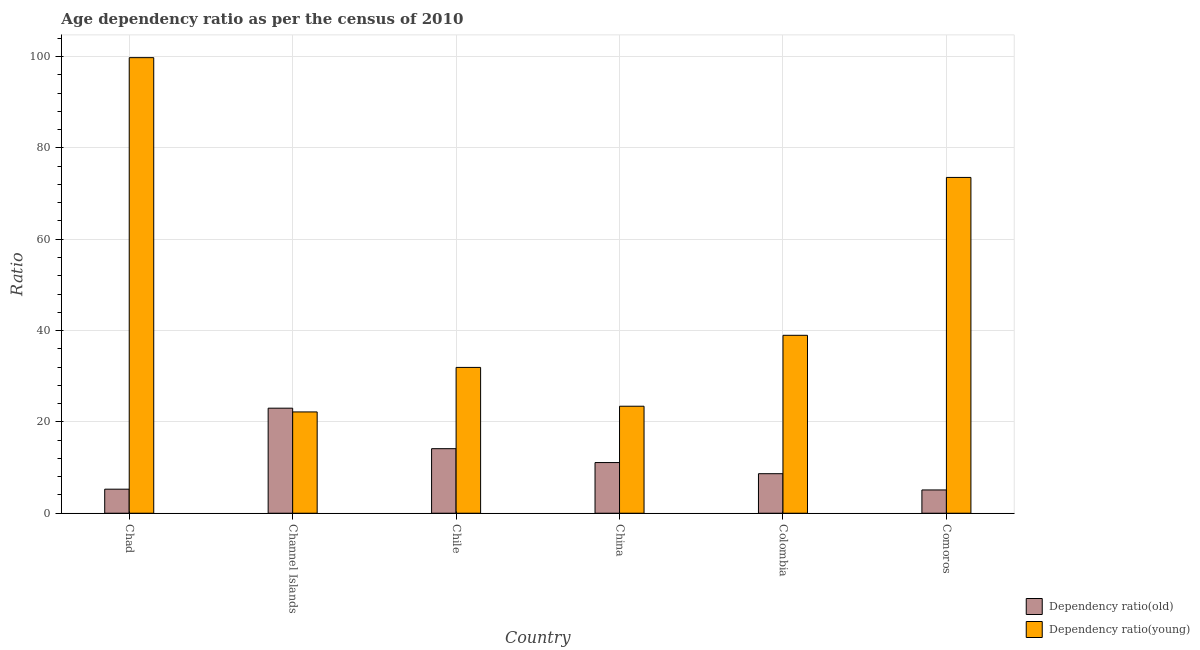How many bars are there on the 3rd tick from the right?
Provide a short and direct response. 2. What is the label of the 5th group of bars from the left?
Provide a short and direct response. Colombia. In how many cases, is the number of bars for a given country not equal to the number of legend labels?
Provide a succinct answer. 0. What is the age dependency ratio(old) in Colombia?
Your answer should be very brief. 8.66. Across all countries, what is the maximum age dependency ratio(old)?
Your answer should be compact. 23. Across all countries, what is the minimum age dependency ratio(young)?
Give a very brief answer. 22.18. In which country was the age dependency ratio(old) maximum?
Make the answer very short. Channel Islands. In which country was the age dependency ratio(old) minimum?
Your answer should be compact. Comoros. What is the total age dependency ratio(old) in the graph?
Offer a very short reply. 67.24. What is the difference between the age dependency ratio(young) in Chile and that in Colombia?
Give a very brief answer. -7.03. What is the difference between the age dependency ratio(young) in Channel Islands and the age dependency ratio(old) in Colombia?
Make the answer very short. 13.52. What is the average age dependency ratio(young) per country?
Give a very brief answer. 48.29. What is the difference between the age dependency ratio(old) and age dependency ratio(young) in China?
Make the answer very short. -12.33. In how many countries, is the age dependency ratio(young) greater than 84 ?
Ensure brevity in your answer.  1. What is the ratio of the age dependency ratio(old) in Chad to that in Chile?
Provide a short and direct response. 0.37. Is the age dependency ratio(young) in Colombia less than that in Comoros?
Keep it short and to the point. Yes. Is the difference between the age dependency ratio(young) in Chile and China greater than the difference between the age dependency ratio(old) in Chile and China?
Ensure brevity in your answer.  Yes. What is the difference between the highest and the second highest age dependency ratio(old)?
Offer a very short reply. 8.87. What is the difference between the highest and the lowest age dependency ratio(old)?
Your answer should be very brief. 17.91. In how many countries, is the age dependency ratio(young) greater than the average age dependency ratio(young) taken over all countries?
Provide a short and direct response. 2. What does the 1st bar from the left in Chile represents?
Your answer should be very brief. Dependency ratio(old). What does the 1st bar from the right in Channel Islands represents?
Your response must be concise. Dependency ratio(young). How many bars are there?
Provide a short and direct response. 12. What is the difference between two consecutive major ticks on the Y-axis?
Provide a succinct answer. 20. Where does the legend appear in the graph?
Keep it short and to the point. Bottom right. How many legend labels are there?
Keep it short and to the point. 2. How are the legend labels stacked?
Provide a short and direct response. Vertical. What is the title of the graph?
Offer a terse response. Age dependency ratio as per the census of 2010. What is the label or title of the Y-axis?
Provide a succinct answer. Ratio. What is the Ratio in Dependency ratio(old) in Chad?
Ensure brevity in your answer.  5.26. What is the Ratio of Dependency ratio(young) in Chad?
Offer a very short reply. 99.75. What is the Ratio in Dependency ratio(old) in Channel Islands?
Keep it short and to the point. 23. What is the Ratio in Dependency ratio(young) in Channel Islands?
Your answer should be compact. 22.18. What is the Ratio of Dependency ratio(old) in Chile?
Give a very brief answer. 14.13. What is the Ratio in Dependency ratio(young) in Chile?
Your answer should be compact. 31.93. What is the Ratio in Dependency ratio(old) in China?
Give a very brief answer. 11.09. What is the Ratio of Dependency ratio(young) in China?
Give a very brief answer. 23.43. What is the Ratio in Dependency ratio(old) in Colombia?
Your answer should be very brief. 8.66. What is the Ratio in Dependency ratio(young) in Colombia?
Keep it short and to the point. 38.96. What is the Ratio in Dependency ratio(old) in Comoros?
Provide a short and direct response. 5.1. What is the Ratio of Dependency ratio(young) in Comoros?
Your answer should be very brief. 73.53. Across all countries, what is the maximum Ratio of Dependency ratio(old)?
Make the answer very short. 23. Across all countries, what is the maximum Ratio in Dependency ratio(young)?
Give a very brief answer. 99.75. Across all countries, what is the minimum Ratio of Dependency ratio(old)?
Keep it short and to the point. 5.1. Across all countries, what is the minimum Ratio in Dependency ratio(young)?
Make the answer very short. 22.18. What is the total Ratio in Dependency ratio(old) in the graph?
Your answer should be very brief. 67.24. What is the total Ratio in Dependency ratio(young) in the graph?
Give a very brief answer. 289.77. What is the difference between the Ratio of Dependency ratio(old) in Chad and that in Channel Islands?
Offer a very short reply. -17.74. What is the difference between the Ratio in Dependency ratio(young) in Chad and that in Channel Islands?
Offer a very short reply. 77.57. What is the difference between the Ratio in Dependency ratio(old) in Chad and that in Chile?
Provide a short and direct response. -8.87. What is the difference between the Ratio in Dependency ratio(young) in Chad and that in Chile?
Your response must be concise. 67.83. What is the difference between the Ratio in Dependency ratio(old) in Chad and that in China?
Offer a very short reply. -5.83. What is the difference between the Ratio of Dependency ratio(young) in Chad and that in China?
Make the answer very short. 76.33. What is the difference between the Ratio in Dependency ratio(old) in Chad and that in Colombia?
Offer a very short reply. -3.39. What is the difference between the Ratio of Dependency ratio(young) in Chad and that in Colombia?
Your answer should be compact. 60.79. What is the difference between the Ratio in Dependency ratio(old) in Chad and that in Comoros?
Keep it short and to the point. 0.17. What is the difference between the Ratio of Dependency ratio(young) in Chad and that in Comoros?
Keep it short and to the point. 26.23. What is the difference between the Ratio of Dependency ratio(old) in Channel Islands and that in Chile?
Provide a succinct answer. 8.87. What is the difference between the Ratio of Dependency ratio(young) in Channel Islands and that in Chile?
Provide a short and direct response. -9.75. What is the difference between the Ratio of Dependency ratio(old) in Channel Islands and that in China?
Keep it short and to the point. 11.91. What is the difference between the Ratio of Dependency ratio(young) in Channel Islands and that in China?
Offer a terse response. -1.25. What is the difference between the Ratio in Dependency ratio(old) in Channel Islands and that in Colombia?
Keep it short and to the point. 14.35. What is the difference between the Ratio of Dependency ratio(young) in Channel Islands and that in Colombia?
Keep it short and to the point. -16.78. What is the difference between the Ratio of Dependency ratio(old) in Channel Islands and that in Comoros?
Provide a succinct answer. 17.91. What is the difference between the Ratio of Dependency ratio(young) in Channel Islands and that in Comoros?
Give a very brief answer. -51.35. What is the difference between the Ratio in Dependency ratio(old) in Chile and that in China?
Offer a terse response. 3.04. What is the difference between the Ratio in Dependency ratio(young) in Chile and that in China?
Keep it short and to the point. 8.5. What is the difference between the Ratio of Dependency ratio(old) in Chile and that in Colombia?
Provide a short and direct response. 5.48. What is the difference between the Ratio of Dependency ratio(young) in Chile and that in Colombia?
Provide a succinct answer. -7.03. What is the difference between the Ratio in Dependency ratio(old) in Chile and that in Comoros?
Your response must be concise. 9.03. What is the difference between the Ratio of Dependency ratio(young) in Chile and that in Comoros?
Your answer should be compact. -41.6. What is the difference between the Ratio in Dependency ratio(old) in China and that in Colombia?
Offer a terse response. 2.44. What is the difference between the Ratio of Dependency ratio(young) in China and that in Colombia?
Ensure brevity in your answer.  -15.53. What is the difference between the Ratio in Dependency ratio(old) in China and that in Comoros?
Your answer should be compact. 6. What is the difference between the Ratio in Dependency ratio(young) in China and that in Comoros?
Provide a short and direct response. -50.1. What is the difference between the Ratio of Dependency ratio(old) in Colombia and that in Comoros?
Your answer should be very brief. 3.56. What is the difference between the Ratio in Dependency ratio(young) in Colombia and that in Comoros?
Make the answer very short. -34.57. What is the difference between the Ratio of Dependency ratio(old) in Chad and the Ratio of Dependency ratio(young) in Channel Islands?
Offer a very short reply. -16.92. What is the difference between the Ratio in Dependency ratio(old) in Chad and the Ratio in Dependency ratio(young) in Chile?
Offer a very short reply. -26.66. What is the difference between the Ratio of Dependency ratio(old) in Chad and the Ratio of Dependency ratio(young) in China?
Offer a terse response. -18.16. What is the difference between the Ratio of Dependency ratio(old) in Chad and the Ratio of Dependency ratio(young) in Colombia?
Your response must be concise. -33.69. What is the difference between the Ratio of Dependency ratio(old) in Chad and the Ratio of Dependency ratio(young) in Comoros?
Provide a short and direct response. -68.26. What is the difference between the Ratio of Dependency ratio(old) in Channel Islands and the Ratio of Dependency ratio(young) in Chile?
Give a very brief answer. -8.93. What is the difference between the Ratio in Dependency ratio(old) in Channel Islands and the Ratio in Dependency ratio(young) in China?
Offer a very short reply. -0.42. What is the difference between the Ratio of Dependency ratio(old) in Channel Islands and the Ratio of Dependency ratio(young) in Colombia?
Ensure brevity in your answer.  -15.96. What is the difference between the Ratio in Dependency ratio(old) in Channel Islands and the Ratio in Dependency ratio(young) in Comoros?
Provide a short and direct response. -50.52. What is the difference between the Ratio of Dependency ratio(old) in Chile and the Ratio of Dependency ratio(young) in China?
Offer a terse response. -9.3. What is the difference between the Ratio in Dependency ratio(old) in Chile and the Ratio in Dependency ratio(young) in Colombia?
Your answer should be very brief. -24.83. What is the difference between the Ratio in Dependency ratio(old) in Chile and the Ratio in Dependency ratio(young) in Comoros?
Keep it short and to the point. -59.39. What is the difference between the Ratio in Dependency ratio(old) in China and the Ratio in Dependency ratio(young) in Colombia?
Offer a very short reply. -27.87. What is the difference between the Ratio of Dependency ratio(old) in China and the Ratio of Dependency ratio(young) in Comoros?
Keep it short and to the point. -62.43. What is the difference between the Ratio of Dependency ratio(old) in Colombia and the Ratio of Dependency ratio(young) in Comoros?
Your response must be concise. -64.87. What is the average Ratio of Dependency ratio(old) per country?
Your answer should be very brief. 11.21. What is the average Ratio of Dependency ratio(young) per country?
Offer a terse response. 48.29. What is the difference between the Ratio of Dependency ratio(old) and Ratio of Dependency ratio(young) in Chad?
Your answer should be compact. -94.49. What is the difference between the Ratio of Dependency ratio(old) and Ratio of Dependency ratio(young) in Channel Islands?
Keep it short and to the point. 0.82. What is the difference between the Ratio in Dependency ratio(old) and Ratio in Dependency ratio(young) in Chile?
Keep it short and to the point. -17.8. What is the difference between the Ratio in Dependency ratio(old) and Ratio in Dependency ratio(young) in China?
Provide a short and direct response. -12.33. What is the difference between the Ratio in Dependency ratio(old) and Ratio in Dependency ratio(young) in Colombia?
Offer a terse response. -30.3. What is the difference between the Ratio in Dependency ratio(old) and Ratio in Dependency ratio(young) in Comoros?
Provide a succinct answer. -68.43. What is the ratio of the Ratio in Dependency ratio(old) in Chad to that in Channel Islands?
Your answer should be very brief. 0.23. What is the ratio of the Ratio in Dependency ratio(young) in Chad to that in Channel Islands?
Your answer should be compact. 4.5. What is the ratio of the Ratio of Dependency ratio(old) in Chad to that in Chile?
Offer a very short reply. 0.37. What is the ratio of the Ratio of Dependency ratio(young) in Chad to that in Chile?
Your answer should be compact. 3.12. What is the ratio of the Ratio of Dependency ratio(old) in Chad to that in China?
Your answer should be very brief. 0.47. What is the ratio of the Ratio of Dependency ratio(young) in Chad to that in China?
Your answer should be very brief. 4.26. What is the ratio of the Ratio of Dependency ratio(old) in Chad to that in Colombia?
Your answer should be very brief. 0.61. What is the ratio of the Ratio in Dependency ratio(young) in Chad to that in Colombia?
Provide a succinct answer. 2.56. What is the ratio of the Ratio of Dependency ratio(old) in Chad to that in Comoros?
Offer a very short reply. 1.03. What is the ratio of the Ratio in Dependency ratio(young) in Chad to that in Comoros?
Provide a short and direct response. 1.36. What is the ratio of the Ratio in Dependency ratio(old) in Channel Islands to that in Chile?
Your answer should be compact. 1.63. What is the ratio of the Ratio in Dependency ratio(young) in Channel Islands to that in Chile?
Ensure brevity in your answer.  0.69. What is the ratio of the Ratio of Dependency ratio(old) in Channel Islands to that in China?
Keep it short and to the point. 2.07. What is the ratio of the Ratio in Dependency ratio(young) in Channel Islands to that in China?
Offer a terse response. 0.95. What is the ratio of the Ratio of Dependency ratio(old) in Channel Islands to that in Colombia?
Make the answer very short. 2.66. What is the ratio of the Ratio of Dependency ratio(young) in Channel Islands to that in Colombia?
Give a very brief answer. 0.57. What is the ratio of the Ratio of Dependency ratio(old) in Channel Islands to that in Comoros?
Your answer should be very brief. 4.51. What is the ratio of the Ratio of Dependency ratio(young) in Channel Islands to that in Comoros?
Ensure brevity in your answer.  0.3. What is the ratio of the Ratio of Dependency ratio(old) in Chile to that in China?
Offer a very short reply. 1.27. What is the ratio of the Ratio in Dependency ratio(young) in Chile to that in China?
Ensure brevity in your answer.  1.36. What is the ratio of the Ratio of Dependency ratio(old) in Chile to that in Colombia?
Offer a very short reply. 1.63. What is the ratio of the Ratio of Dependency ratio(young) in Chile to that in Colombia?
Make the answer very short. 0.82. What is the ratio of the Ratio in Dependency ratio(old) in Chile to that in Comoros?
Your answer should be compact. 2.77. What is the ratio of the Ratio of Dependency ratio(young) in Chile to that in Comoros?
Provide a short and direct response. 0.43. What is the ratio of the Ratio in Dependency ratio(old) in China to that in Colombia?
Keep it short and to the point. 1.28. What is the ratio of the Ratio in Dependency ratio(young) in China to that in Colombia?
Provide a succinct answer. 0.6. What is the ratio of the Ratio of Dependency ratio(old) in China to that in Comoros?
Your answer should be very brief. 2.18. What is the ratio of the Ratio in Dependency ratio(young) in China to that in Comoros?
Offer a very short reply. 0.32. What is the ratio of the Ratio of Dependency ratio(old) in Colombia to that in Comoros?
Provide a short and direct response. 1.7. What is the ratio of the Ratio in Dependency ratio(young) in Colombia to that in Comoros?
Your response must be concise. 0.53. What is the difference between the highest and the second highest Ratio of Dependency ratio(old)?
Keep it short and to the point. 8.87. What is the difference between the highest and the second highest Ratio of Dependency ratio(young)?
Make the answer very short. 26.23. What is the difference between the highest and the lowest Ratio in Dependency ratio(old)?
Provide a succinct answer. 17.91. What is the difference between the highest and the lowest Ratio of Dependency ratio(young)?
Your answer should be very brief. 77.57. 